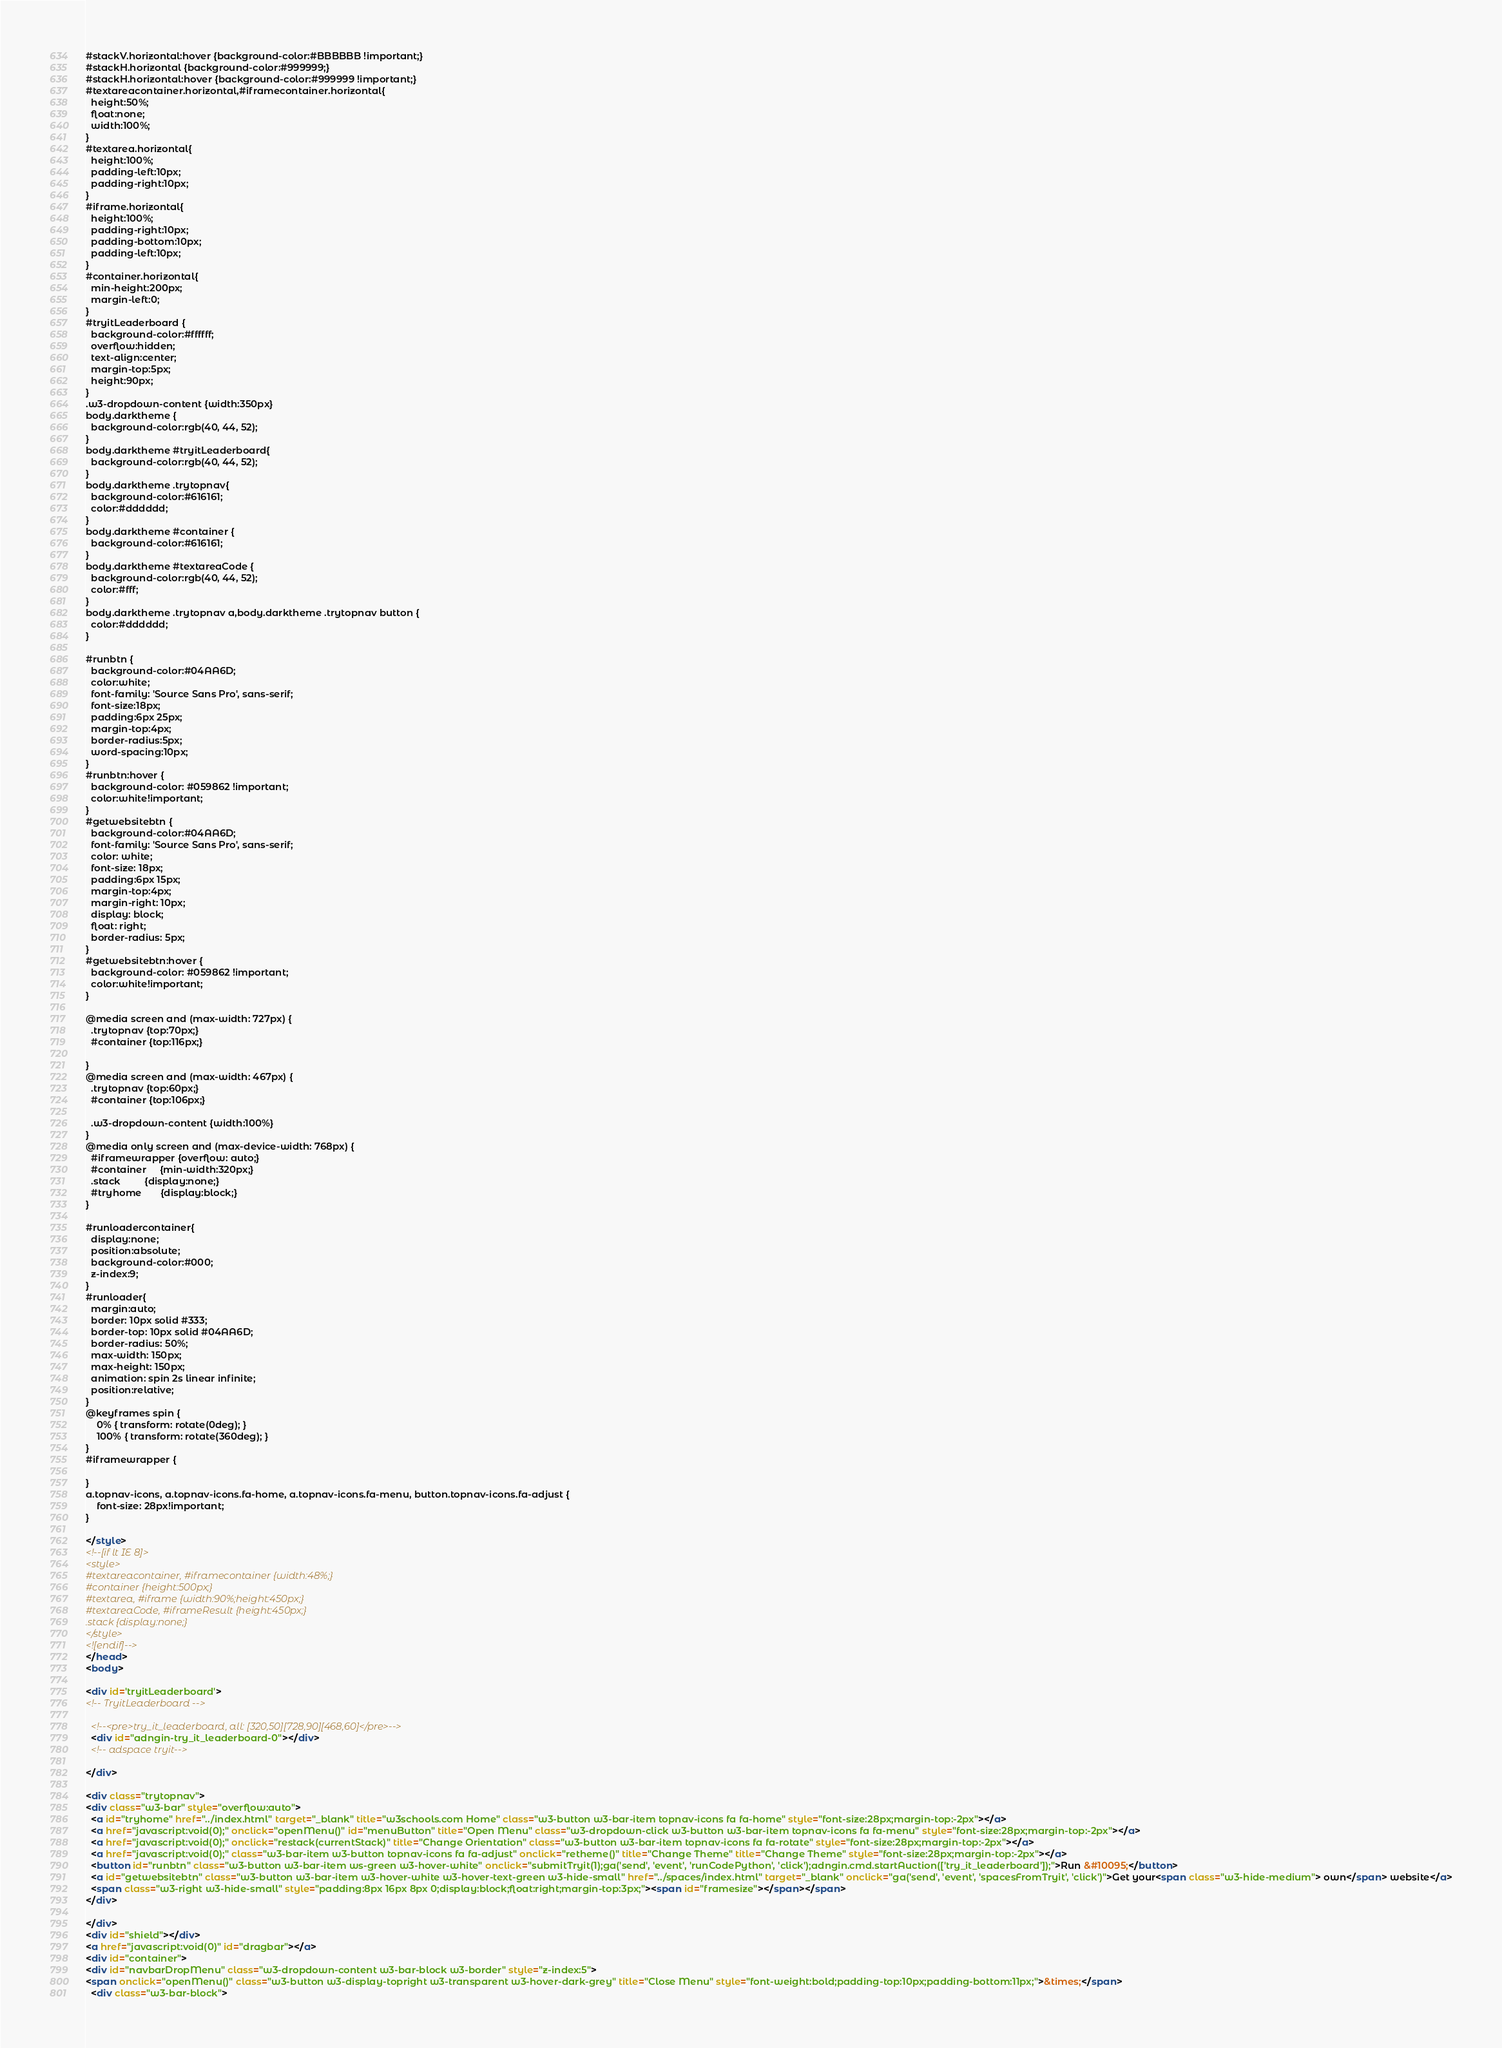Convert code to text. <code><loc_0><loc_0><loc_500><loc_500><_HTML_>#stackV.horizontal:hover {background-color:#BBBBBB !important;}
#stackH.horizontal {background-color:#999999;}
#stackH.horizontal:hover {background-color:#999999 !important;}
#textareacontainer.horizontal,#iframecontainer.horizontal{
  height:50%;
  float:none;
  width:100%;
}
#textarea.horizontal{
  height:100%;
  padding-left:10px;
  padding-right:10px;
}
#iframe.horizontal{
  height:100%;
  padding-right:10px;
  padding-bottom:10px;
  padding-left:10px;  
}
#container.horizontal{
  min-height:200px;
  margin-left:0;
}
#tryitLeaderboard {
  background-color:#ffffff;
  overflow:hidden;
  text-align:center;
  margin-top:5px;
  height:90px;
}
.w3-dropdown-content {width:350px}
body.darktheme {
  background-color:rgb(40, 44, 52);
}
body.darktheme #tryitLeaderboard{
  background-color:rgb(40, 44, 52);
}
body.darktheme .trytopnav{
  background-color:#616161;
  color:#dddddd;
}
body.darktheme #container {
  background-color:#616161;
}
body.darktheme #textareaCode {
  background-color:rgb(40, 44, 52);
  color:#fff;
}
body.darktheme .trytopnav a,body.darktheme .trytopnav button {
  color:#dddddd;
}

#runbtn {
  background-color:#04AA6D;
  color:white;
  font-family: 'Source Sans Pro', sans-serif;
  font-size:18px;
  padding:6px 25px;
  margin-top:4px;
  border-radius:5px;
  word-spacing:10px;
}
#runbtn:hover {
  background-color: #059862 !important;
  color:white!important;
}
#getwebsitebtn {
  background-color:#04AA6D;
  font-family: 'Source Sans Pro', sans-serif;  
  color: white;
  font-size: 18px;
  padding:6px 15px;
  margin-top:4px;
  margin-right: 10px;
  display: block;
  float: right;
  border-radius: 5px;
}
#getwebsitebtn:hover {
  background-color: #059862 !important;
  color:white!important;
}
  
@media screen and (max-width: 727px) {
  .trytopnav {top:70px;}
  #container {top:116px;}

}
@media screen and (max-width: 467px) {
  .trytopnav {top:60px;}
  #container {top:106px;}
  
  .w3-dropdown-content {width:100%}
}
@media only screen and (max-device-width: 768px) {
  #iframewrapper {overflow: auto;}
  #container     {min-width:320px;}
  .stack         {display:none;}
  #tryhome       {display:block;}
}

#runloadercontainer{
  display:none;
  position:absolute;
  background-color:#000;
  z-index:9;
}
#runloader{
  margin:auto;
  border: 10px solid #333;
  border-top: 10px solid #04AA6D;
  border-radius: 50%;
  max-width: 150px;
  max-height: 150px;
  animation: spin 2s linear infinite;
  position:relative;
}
@keyframes spin {
    0% { transform: rotate(0deg); }
    100% { transform: rotate(360deg); }
}
#iframewrapper {
	
}
a.topnav-icons, a.topnav-icons.fa-home, a.topnav-icons.fa-menu, button.topnav-icons.fa-adjust {
    font-size: 28px!important;
}

</style>
<!--[if lt IE 8]>
<style>
#textareacontainer, #iframecontainer {width:48%;}
#container {height:500px;}
#textarea, #iframe {width:90%;height:450px;}
#textareaCode, #iframeResult {height:450px;}
.stack {display:none;}
</style>
<![endif]-->
</head>
<body>

<div id='tryitLeaderboard'>
<!-- TryitLeaderboard -->

  <!--<pre>try_it_leaderboard, all: [320,50][728,90][468,60]</pre>-->
  <div id="adngin-try_it_leaderboard-0"></div>
  <!-- adspace tryit-->
 
</div>

<div class="trytopnav">
<div class="w3-bar" style="overflow:auto">
  <a id="tryhome" href="../index.html" target="_blank" title="w3schools.com Home" class="w3-button w3-bar-item topnav-icons fa fa-home" style="font-size:28px;margin-top:-2px"></a>
  <a href="javascript:void(0);" onclick="openMenu()" id="menuButton" title="Open Menu" class="w3-dropdown-click w3-button w3-bar-item topnav-icons fa fa-menu" style="font-size:28px;margin-top:-2px"></a>
  <a href="javascript:void(0);" onclick="restack(currentStack)" title="Change Orientation" class="w3-button w3-bar-item topnav-icons fa fa-rotate" style="font-size:28px;margin-top:-2px"></a>
  <a href="javascript:void(0);" class="w3-bar-item w3-button topnav-icons fa fa-adjust" onclick="retheme()" title="Change Theme" title="Change Theme" style="font-size:28px;margin-top:-2px"></a>
  <button id="runbtn" class="w3-button w3-bar-item ws-green w3-hover-white" onclick="submitTryit(1);ga('send', 'event', 'runCodePython', 'click');adngin.cmd.startAuction(['try_it_leaderboard']);">Run &#10095;</button>
  <a id="getwebsitebtn" class="w3-button w3-bar-item w3-hover-white w3-hover-text-green w3-hide-small" href="../spaces/index.html" target="_blank" onclick="ga('send', 'event', 'spacesFromTryit', 'click')">Get your<span class="w3-hide-medium"> own</span> website</a>
  <span class="w3-right w3-hide-small" style="padding:8px 16px 8px 0;display:block;float:right;margin-top:3px;"><span id="framesize"></span></span>
</div>

</div>
<div id="shield"></div>
<a href="javascript:void(0)" id="dragbar"></a>
<div id="container">
<div id="navbarDropMenu" class="w3-dropdown-content w3-bar-block w3-border" style="z-index:5">
<span onclick="openMenu()" class="w3-button w3-display-topright w3-transparent w3-hover-dark-grey" title="Close Menu" style="font-weight:bold;padding-top:10px;padding-bottom:11px;">&times;</span>
  <div class="w3-bar-block"></code> 